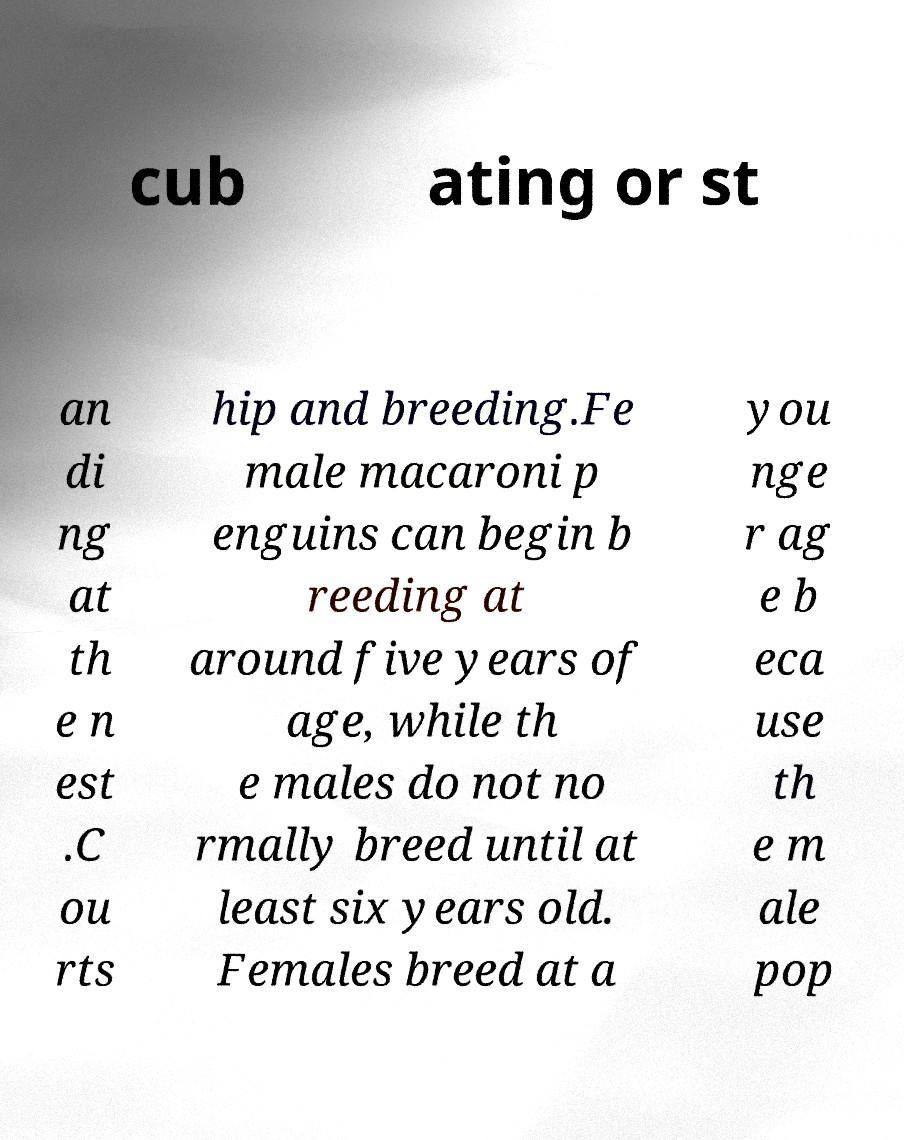What messages or text are displayed in this image? I need them in a readable, typed format. cub ating or st an di ng at th e n est .C ou rts hip and breeding.Fe male macaroni p enguins can begin b reeding at around five years of age, while th e males do not no rmally breed until at least six years old. Females breed at a you nge r ag e b eca use th e m ale pop 